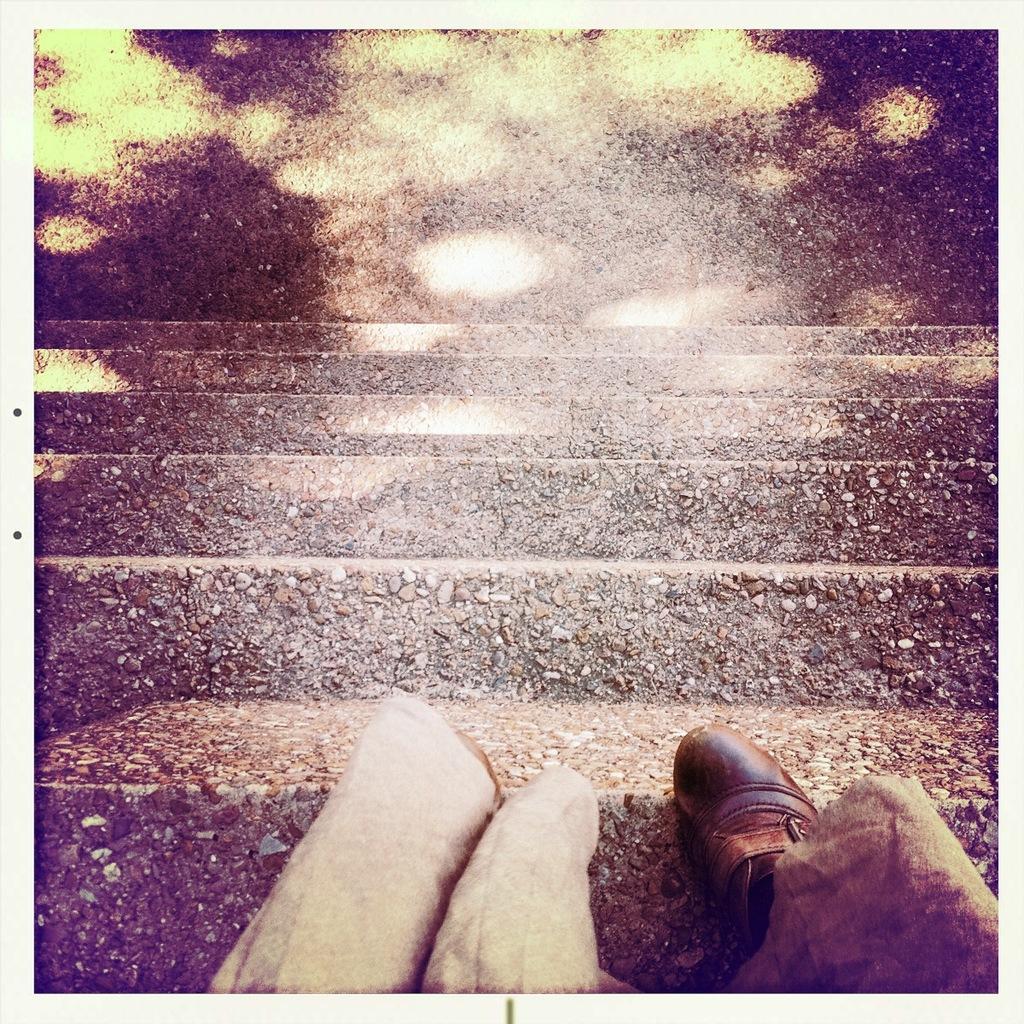Please provide a concise description of this image. In this image we can see the legs of a person on the staircase. 